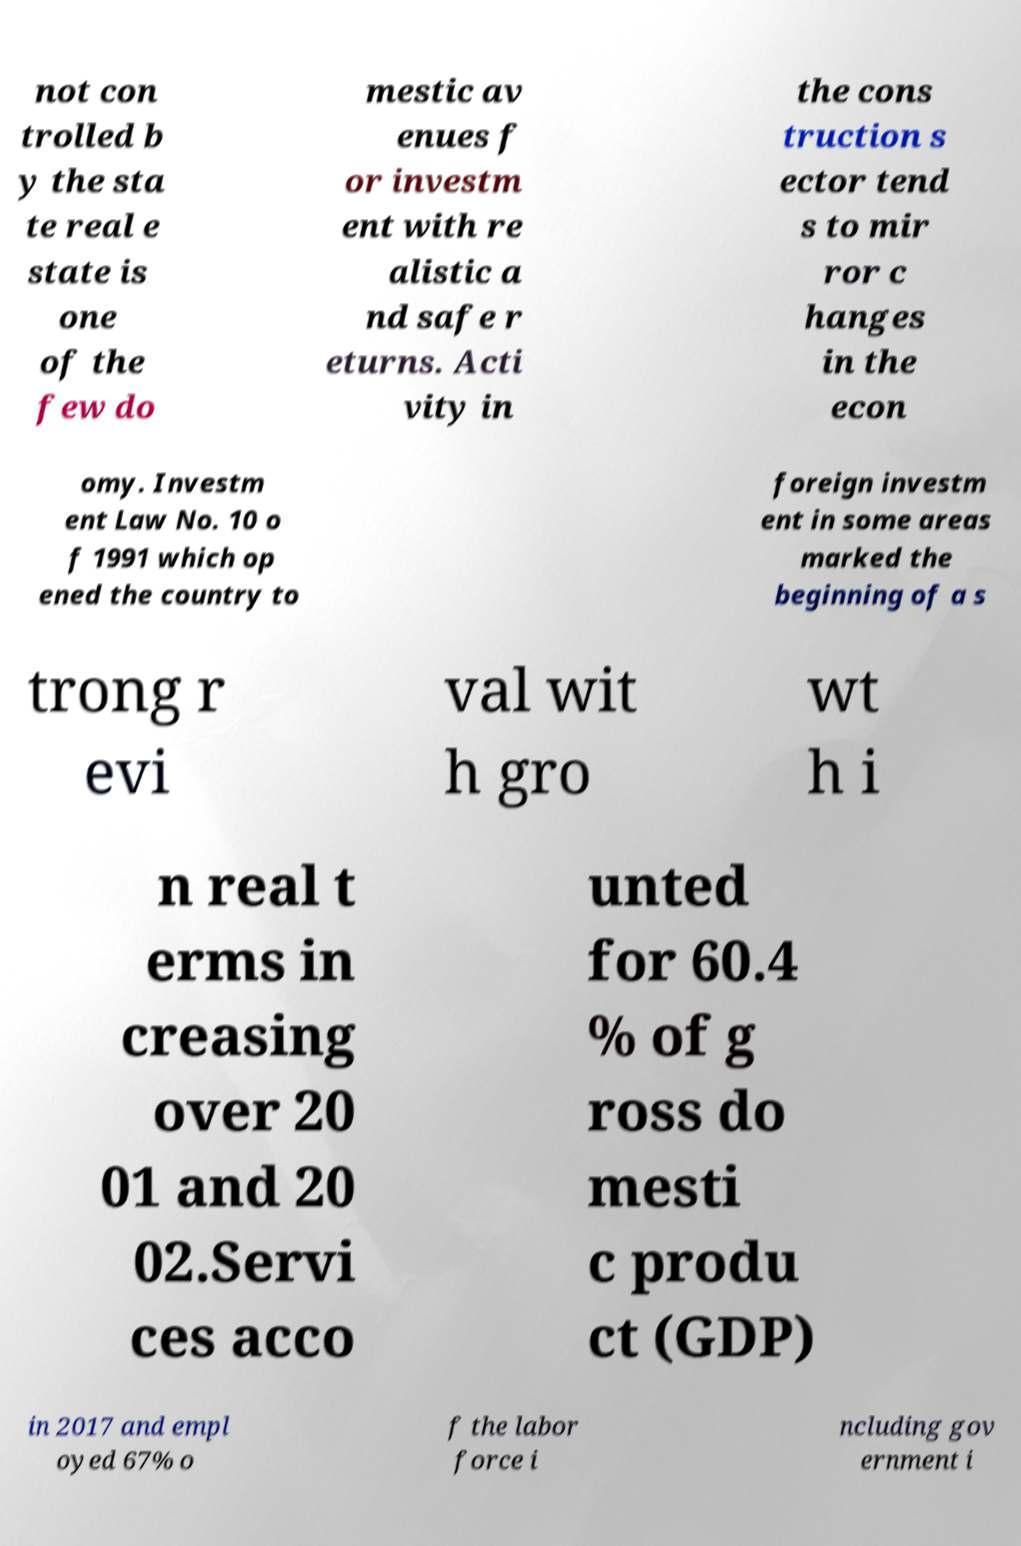I need the written content from this picture converted into text. Can you do that? not con trolled b y the sta te real e state is one of the few do mestic av enues f or investm ent with re alistic a nd safe r eturns. Acti vity in the cons truction s ector tend s to mir ror c hanges in the econ omy. Investm ent Law No. 10 o f 1991 which op ened the country to foreign investm ent in some areas marked the beginning of a s trong r evi val wit h gro wt h i n real t erms in creasing over 20 01 and 20 02.Servi ces acco unted for 60.4 % of g ross do mesti c produ ct (GDP) in 2017 and empl oyed 67% o f the labor force i ncluding gov ernment i 